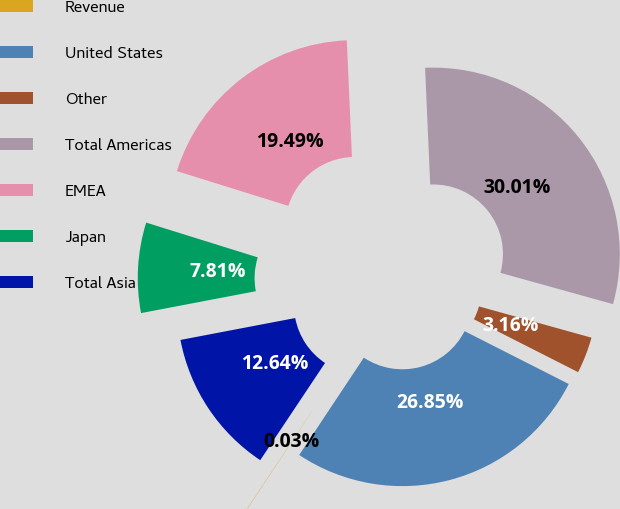<chart> <loc_0><loc_0><loc_500><loc_500><pie_chart><fcel>Revenue<fcel>United States<fcel>Other<fcel>Total Americas<fcel>EMEA<fcel>Japan<fcel>Total Asia<nl><fcel>0.03%<fcel>26.85%<fcel>3.16%<fcel>30.01%<fcel>19.49%<fcel>7.81%<fcel>12.64%<nl></chart> 